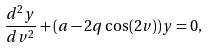Convert formula to latex. <formula><loc_0><loc_0><loc_500><loc_500>\frac { d ^ { 2 } y } { d v ^ { 2 } } + ( a - 2 q \cos ( 2 v ) ) y = 0 ,</formula> 